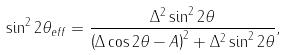<formula> <loc_0><loc_0><loc_500><loc_500>\sin ^ { 2 } 2 \theta _ { e f f } = { \frac { \Delta ^ { 2 } \sin ^ { 2 } 2 \theta } { \left ( \Delta \cos 2 \theta - A \right ) ^ { 2 } + \Delta ^ { 2 } \sin ^ { 2 } 2 \theta } } ,</formula> 